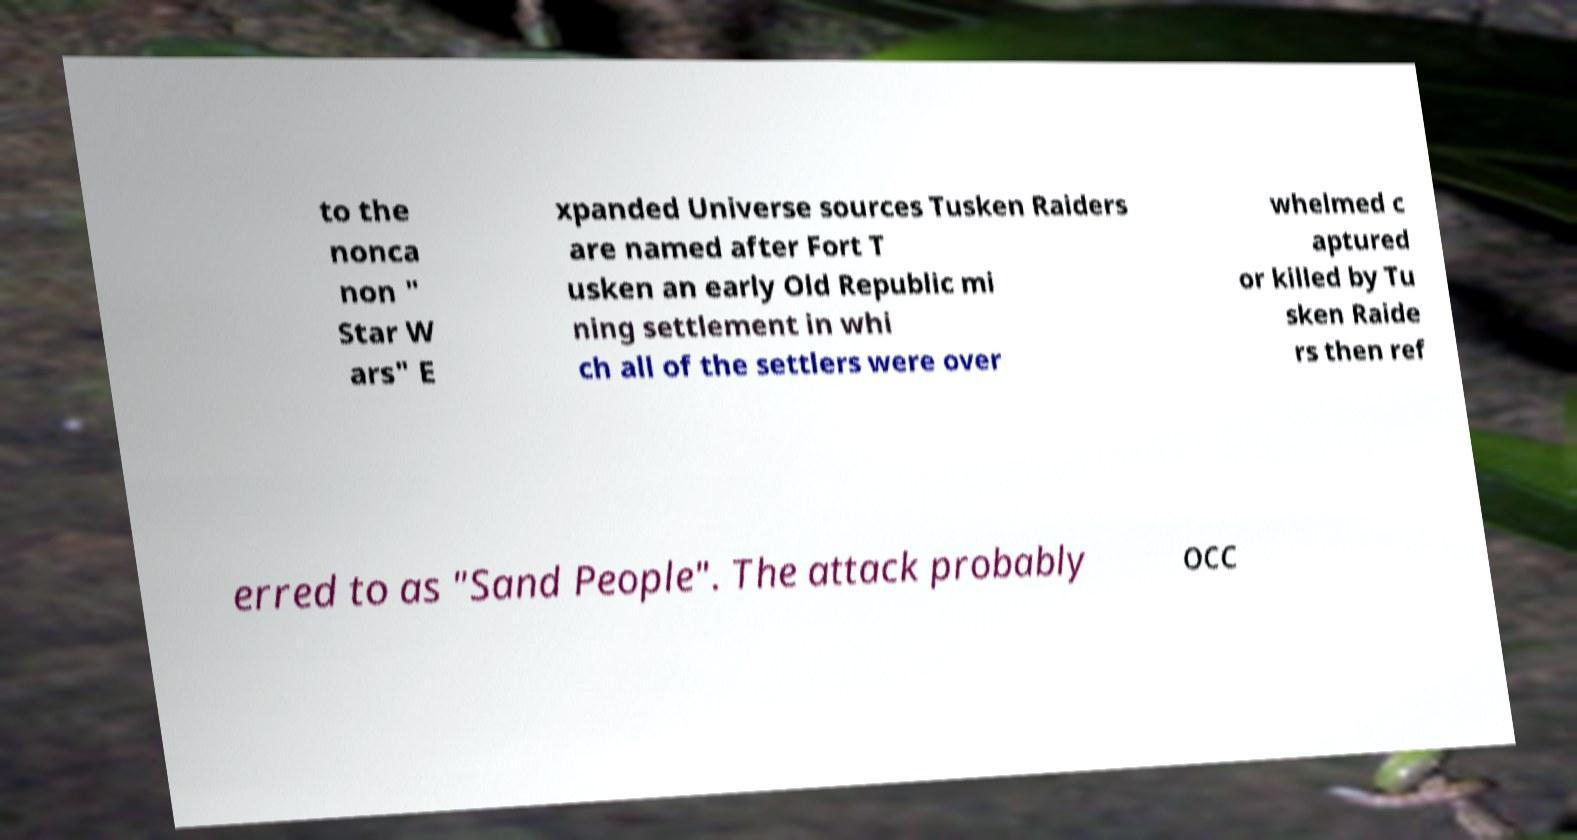What messages or text are displayed in this image? I need them in a readable, typed format. to the nonca non " Star W ars" E xpanded Universe sources Tusken Raiders are named after Fort T usken an early Old Republic mi ning settlement in whi ch all of the settlers were over whelmed c aptured or killed by Tu sken Raide rs then ref erred to as "Sand People". The attack probably occ 